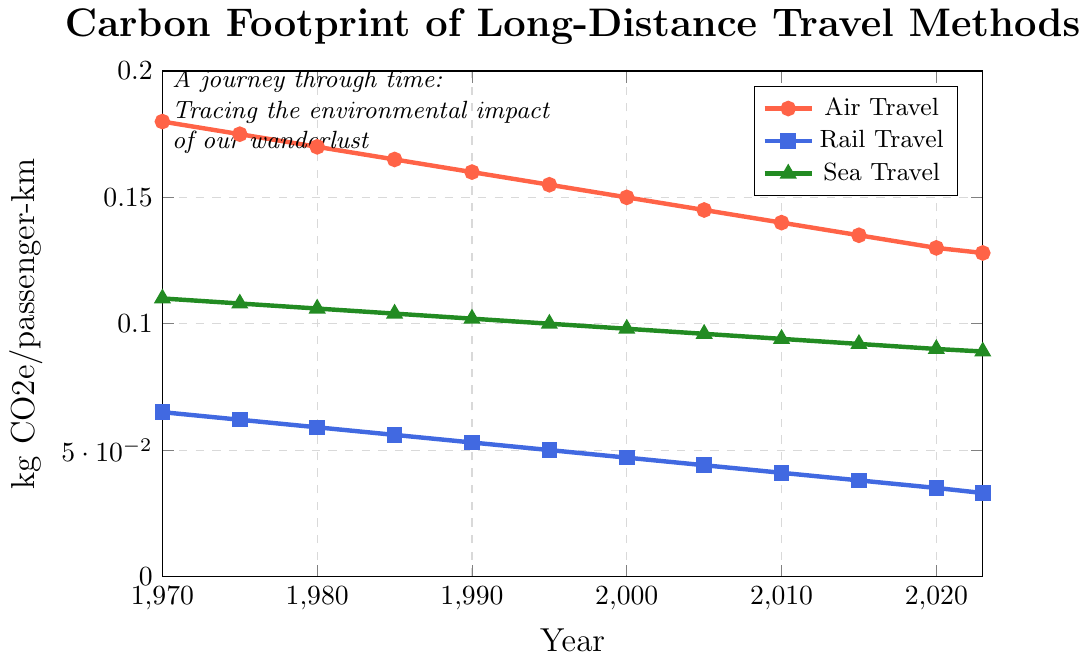What's the overall trend for the carbon footprint of air travel from 1970 to 2023? The carbon footprint of air travel shows a decreasing trend from 0.180 kg CO2e/passenger-km in 1970 to 0.128 kg CO2e/passenger-km in 2023. This indicates a continuous reduction over the years.
Answer: Decreasing Which travel method had the lowest carbon footprint in 2023? In 2023, rail travel has the lowest carbon footprint at 0.033 kg CO2e/passenger-km, compared to air travel at 0.128 kg CO2e/passenger-km and sea travel at 0.089 kg CO2e/passenger-km.
Answer: Rail travel By how much did the carbon footprint of sea travel decrease from 1970 to 2023? In 1970, the carbon footprint for sea travel was 0.110 kg CO2e/passenger-km. By 2023, it had decreased to 0.089 kg CO2e/passenger-km. The difference is 0.110 - 0.089 = 0.021 kg CO2e/passenger-km.
Answer: 0.021 kg CO2e/passenger-km Between which years did rail travel see the largest reduction in its carbon footprint? The largest reduction for rail travel appears between 2010 and 2015, where it decreased from 0.041 to 0.038 kg CO2e/passenger-km, a reduction of 0.003 kg CO2e/passenger-km. This is the most significant drop compared to other periods.
Answer: 2010 to 2015 In which year did air travel's carbon footprint first drop below 0.150 kg CO2e/passenger-km? Referring to the data points, air travel's carbon footprint first dropped below 0.150 kg CO2e/passenger-km in the year 2000.
Answer: 2000 Rank the transportation methods based on their carbon footprint in 1990 from highest to lowest. In 1990, the carbon footprints were: air travel = 0.160 kg CO2e/passenger-km, sea travel = 0.102 kg CO2e/passenger-km, and rail travel = 0.053 kg CO2e/passenger-km. Therefore, the ranking from highest to lowest is: air travel > sea travel > rail travel.
Answer: Air travel > Sea travel > Rail travel Calculate the average carbon footprint of rail travel from 1970 to 2023. The values for rail travel are (0.065, 0.062, 0.059, 0.056, 0.053, 0.050, 0.047, 0.044, 0.041, 0.038, 0.035, 0.033). Adding these gives 0.623. There are 12 data points, so the average is 0.623/12 = 0.0519 kg CO2e/passenger-km.
Answer: 0.0519 kg CO2e/passenger-km Which travel method shows the most significant overall decrease in carbon footprint from 1970 to 2023? From 1970 to 2023, the decreases are air travel: 0.052 kg CO2e/passenger-km (0.180 to 0.128), rail travel: 0.032 kg CO2e/passenger-km (0.065 to 0.033), and sea travel: 0.021 kg CO2e/passenger-km (0.110 to 0.089). Air travel shows the most significant overall decrease.
Answer: Air travel How much did the carbon footprint of rail travel reduce as a percentage from 1970 to 2023? Initial value for rail travel in 1970 is 0.065 kg CO2e/passenger-km, and in 2023 it is 0.033 kg CO2e/passenger-km. The reduction is 0.065 - 0.033 = 0.032 kg CO2e/passenger-km. The percentage reduction is (0.032 / 0.065) * 100 = 49.23%.
Answer: 49.23% 